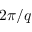Convert formula to latex. <formula><loc_0><loc_0><loc_500><loc_500>2 \pi / q</formula> 